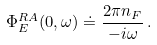<formula> <loc_0><loc_0><loc_500><loc_500>\Phi ^ { R A } _ { E } ( 0 , \omega ) \doteq \frac { 2 \pi n _ { F } } { - i \omega } \, .</formula> 